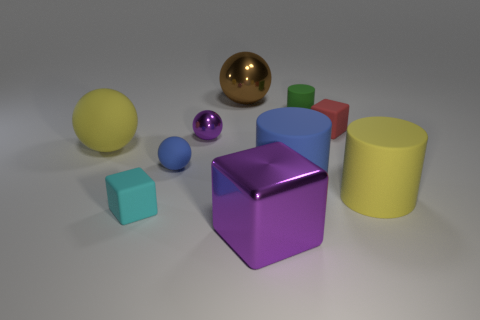Is there a big metallic cube that has the same color as the tiny metallic thing?
Give a very brief answer. Yes. Does the big purple block have the same material as the yellow thing left of the large block?
Your answer should be compact. No. What number of tiny objects are either cyan matte cubes or brown spheres?
Your answer should be compact. 1. There is a small thing that is the same color as the metallic cube; what is its material?
Keep it short and to the point. Metal. Are there fewer tiny brown matte balls than small blue matte balls?
Give a very brief answer. Yes. Do the rubber cylinder behind the tiny red block and the rubber cube to the left of the big shiny cube have the same size?
Offer a very short reply. Yes. How many brown objects are either large metal cylinders or metal things?
Keep it short and to the point. 1. There is a rubber cylinder that is the same color as the small rubber sphere; what size is it?
Your answer should be compact. Large. Are there more large rubber cylinders than yellow cylinders?
Your response must be concise. Yes. Is the color of the small metal sphere the same as the big cube?
Offer a terse response. Yes. 